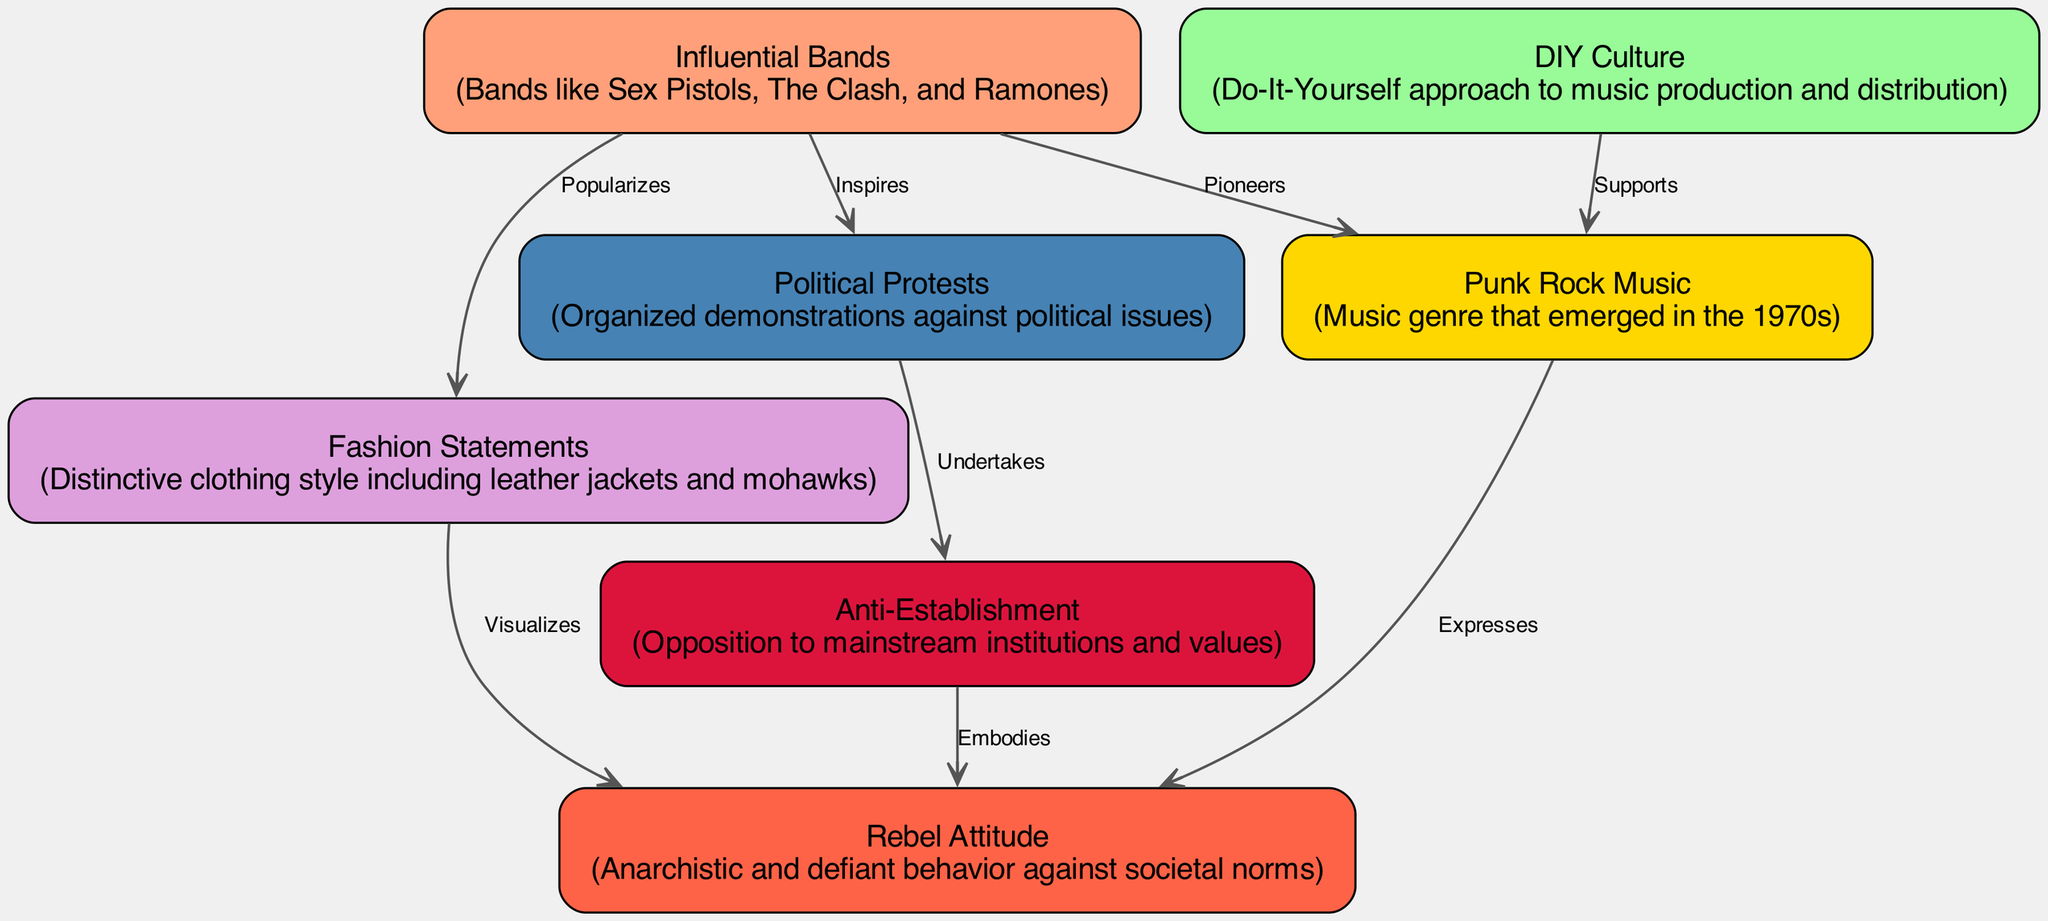What is the total number of nodes in the diagram? There are 7 nodes listed in the data: punk rock music, rebel attitude, DIY culture, anti-establishment, fashion statements, political protests, and influential bands. Thus, the total number of nodes is 7.
Answer: 7 Which node expresses a rebel attitude? The edge from the punk rock music node to the rebel attitude node is labeled "Expresses," indicating that punk rock music is the node that expresses a rebel attitude.
Answer: punk rock music What does the DIY culture support? The edge between the DIY culture node and the punk rock music node is labeled "Supports," meaning DIY culture supports punk rock music.
Answer: punk rock music How many edges are connected to the influential bands node? The influential bands node has three edges connected to it, one each to punk rock music, political protests, and fashion statements. Thus, there are 3 edges connected to the influential bands node.
Answer: 3 Which node visualizes rebel attitude? The edge from fashion statements to rebel attitude is labeled "Visualizes," showing that fashion statements visualize the rebel attitude.
Answer: fashion statements What do political protests undertake? The edge from political protests to anti-establishment is labeled "Undertakes," indicating that political protests undertake actions against anti-establishment values.
Answer: anti-establishment What are the influential bands known for pioneering? The edge from influential bands to punk rock music is labeled "Pioneers," meaning influential bands are known for pioneering punk rock music.
Answer: punk rock music Which node is associated with organizing demonstrations? The node that is connected to the political protests by the edge labeled "Undertakes" indicates organizing demonstrations against political issues, so political protests is the associated node.
Answer: political protests How does the anti-establishment embody rebel attitude? The edge from anti-establishment to rebel attitude is labeled "Embodies," which signifies that the anti-establishment movement embodies the characteristics of a rebel attitude.
Answer: anti-establishment 